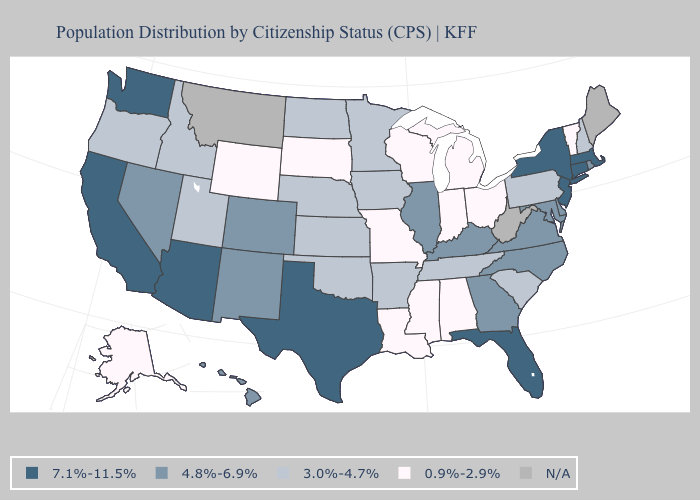What is the value of New Mexico?
Keep it brief. 4.8%-6.9%. Name the states that have a value in the range 4.8%-6.9%?
Keep it brief. Colorado, Delaware, Georgia, Hawaii, Illinois, Kentucky, Maryland, Nevada, New Mexico, North Carolina, Rhode Island, Virginia. Does the map have missing data?
Keep it brief. Yes. What is the value of North Carolina?
Write a very short answer. 4.8%-6.9%. What is the highest value in states that border Oregon?
Keep it brief. 7.1%-11.5%. What is the value of North Carolina?
Short answer required. 4.8%-6.9%. What is the highest value in the Northeast ?
Quick response, please. 7.1%-11.5%. Among the states that border North Carolina , does Georgia have the highest value?
Short answer required. Yes. What is the highest value in the MidWest ?
Concise answer only. 4.8%-6.9%. What is the value of Massachusetts?
Short answer required. 7.1%-11.5%. What is the value of Pennsylvania?
Concise answer only. 3.0%-4.7%. Does Michigan have the lowest value in the USA?
Give a very brief answer. Yes. Which states have the lowest value in the USA?
Answer briefly. Alabama, Alaska, Indiana, Louisiana, Michigan, Mississippi, Missouri, Ohio, South Dakota, Vermont, Wisconsin, Wyoming. 